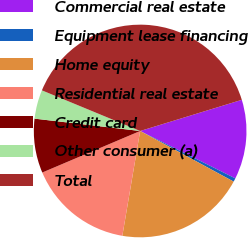<chart> <loc_0><loc_0><loc_500><loc_500><pie_chart><fcel>Commercial real estate<fcel>Equipment lease financing<fcel>Home equity<fcel>Residential real estate<fcel>Credit card<fcel>Other consumer (a)<fcel>Total<nl><fcel>12.09%<fcel>0.54%<fcel>19.78%<fcel>15.93%<fcel>8.24%<fcel>4.39%<fcel>39.02%<nl></chart> 